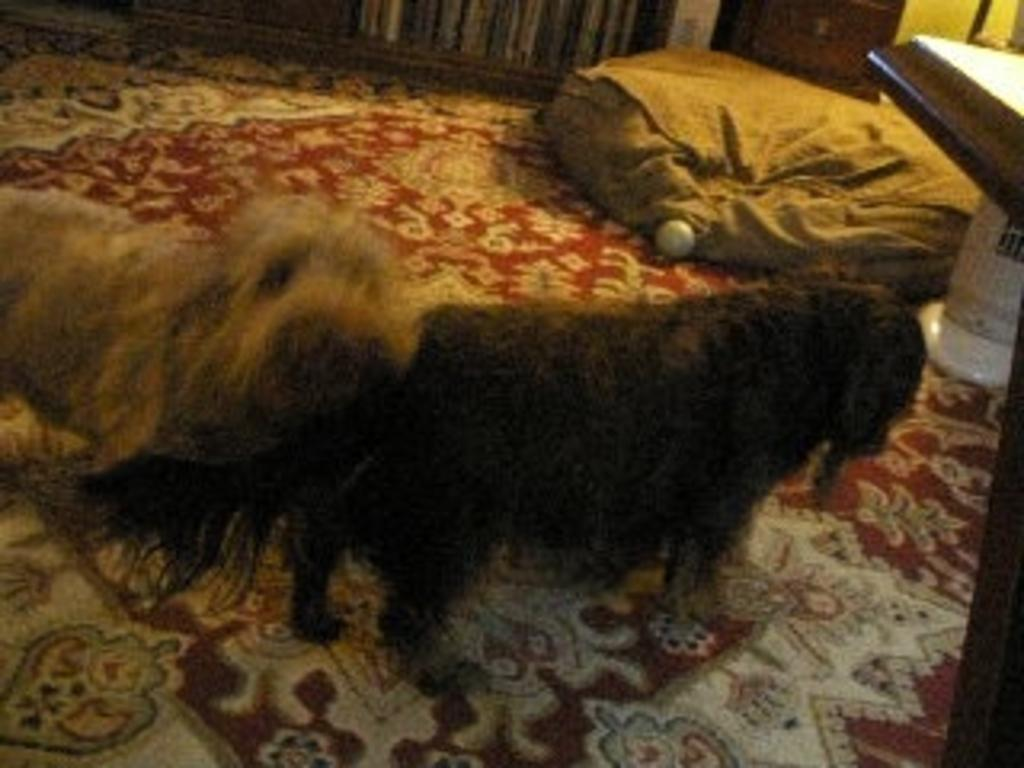How many animals are present in the image? There are two animals in the image. What colors are the animals? The animals are in brown and black colors. What other objects can be seen in the image? There is a brown color bag and a red and white color floor mat in the image. Can you describe the surroundings of the animals? There are objects visible around the animals. Do the animals in the image express any feelings of hate towards each other? There is no indication of emotions or feelings in the image, so it cannot be determined if the animals express any feelings of hate towards each other. 